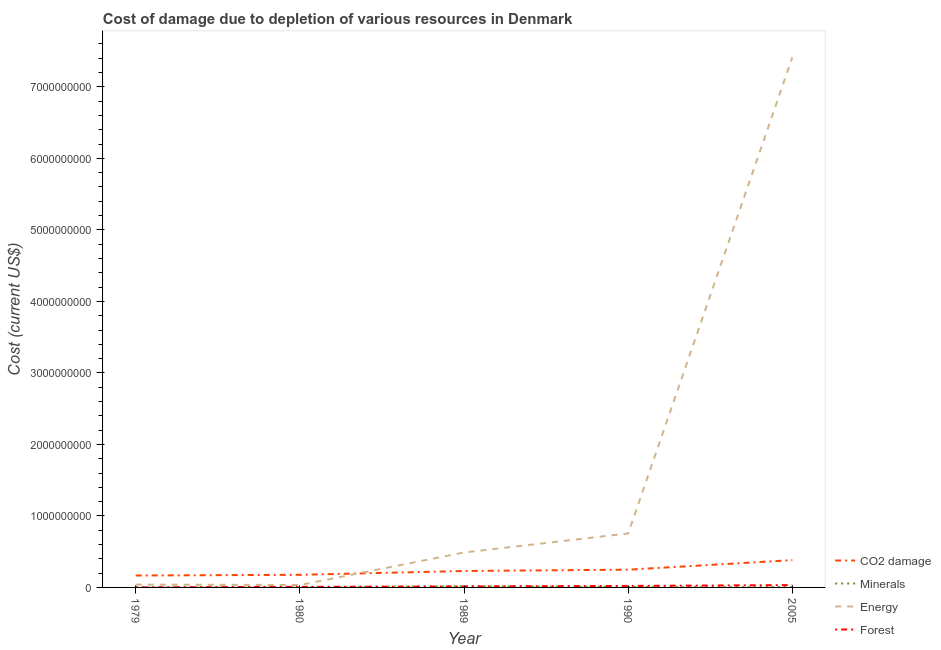How many different coloured lines are there?
Ensure brevity in your answer.  4. Is the number of lines equal to the number of legend labels?
Give a very brief answer. Yes. What is the cost of damage due to depletion of coal in 1989?
Keep it short and to the point. 2.30e+08. Across all years, what is the maximum cost of damage due to depletion of coal?
Ensure brevity in your answer.  3.82e+08. Across all years, what is the minimum cost of damage due to depletion of energy?
Provide a short and direct response. 3.40e+07. In which year was the cost of damage due to depletion of energy maximum?
Your response must be concise. 2005. In which year was the cost of damage due to depletion of forests minimum?
Make the answer very short. 1979. What is the total cost of damage due to depletion of coal in the graph?
Give a very brief answer. 1.20e+09. What is the difference between the cost of damage due to depletion of minerals in 1979 and that in 1989?
Offer a terse response. -1.66e+07. What is the difference between the cost of damage due to depletion of energy in 1989 and the cost of damage due to depletion of coal in 1979?
Your answer should be compact. 3.22e+08. What is the average cost of damage due to depletion of minerals per year?
Offer a terse response. 6.03e+06. In the year 1980, what is the difference between the cost of damage due to depletion of minerals and cost of damage due to depletion of forests?
Provide a short and direct response. -6.27e+06. In how many years, is the cost of damage due to depletion of coal greater than 2800000000 US$?
Your response must be concise. 0. What is the ratio of the cost of damage due to depletion of minerals in 1980 to that in 2005?
Give a very brief answer. 0.41. What is the difference between the highest and the second highest cost of damage due to depletion of energy?
Give a very brief answer. 6.66e+09. What is the difference between the highest and the lowest cost of damage due to depletion of minerals?
Offer a terse response. 1.66e+07. In how many years, is the cost of damage due to depletion of coal greater than the average cost of damage due to depletion of coal taken over all years?
Your answer should be compact. 2. Is the sum of the cost of damage due to depletion of coal in 1989 and 2005 greater than the maximum cost of damage due to depletion of minerals across all years?
Your answer should be very brief. Yes. Is it the case that in every year, the sum of the cost of damage due to depletion of coal and cost of damage due to depletion of minerals is greater than the cost of damage due to depletion of energy?
Offer a very short reply. No. Is the cost of damage due to depletion of energy strictly greater than the cost of damage due to depletion of forests over the years?
Give a very brief answer. Yes. Is the cost of damage due to depletion of energy strictly less than the cost of damage due to depletion of minerals over the years?
Offer a terse response. No. How many lines are there?
Your answer should be compact. 4. How many years are there in the graph?
Keep it short and to the point. 5. What is the difference between two consecutive major ticks on the Y-axis?
Offer a terse response. 1.00e+09. Are the values on the major ticks of Y-axis written in scientific E-notation?
Offer a terse response. No. Does the graph contain any zero values?
Your answer should be compact. No. Where does the legend appear in the graph?
Ensure brevity in your answer.  Bottom right. What is the title of the graph?
Offer a terse response. Cost of damage due to depletion of various resources in Denmark . Does "HFC gas" appear as one of the legend labels in the graph?
Your answer should be very brief. No. What is the label or title of the X-axis?
Your answer should be compact. Year. What is the label or title of the Y-axis?
Offer a terse response. Cost (current US$). What is the Cost (current US$) in CO2 damage in 1979?
Make the answer very short. 1.67e+08. What is the Cost (current US$) of Minerals in 1979?
Provide a short and direct response. 1.76e+05. What is the Cost (current US$) in Energy in 1979?
Provide a short and direct response. 3.92e+07. What is the Cost (current US$) in Forest in 1979?
Your answer should be compact. 5.20e+05. What is the Cost (current US$) in CO2 damage in 1980?
Provide a short and direct response. 1.76e+08. What is the Cost (current US$) of Minerals in 1980?
Your answer should be very brief. 1.95e+06. What is the Cost (current US$) of Energy in 1980?
Provide a short and direct response. 3.40e+07. What is the Cost (current US$) of Forest in 1980?
Offer a very short reply. 8.22e+06. What is the Cost (current US$) of CO2 damage in 1989?
Offer a terse response. 2.30e+08. What is the Cost (current US$) in Minerals in 1989?
Offer a very short reply. 1.68e+07. What is the Cost (current US$) of Energy in 1989?
Your answer should be very brief. 4.89e+08. What is the Cost (current US$) of Forest in 1989?
Offer a terse response. 1.32e+07. What is the Cost (current US$) of CO2 damage in 1990?
Your answer should be compact. 2.48e+08. What is the Cost (current US$) in Minerals in 1990?
Give a very brief answer. 6.54e+06. What is the Cost (current US$) of Energy in 1990?
Keep it short and to the point. 7.55e+08. What is the Cost (current US$) of Forest in 1990?
Your answer should be compact. 2.11e+07. What is the Cost (current US$) of CO2 damage in 2005?
Your answer should be very brief. 3.82e+08. What is the Cost (current US$) of Minerals in 2005?
Provide a succinct answer. 4.71e+06. What is the Cost (current US$) in Energy in 2005?
Your response must be concise. 7.41e+09. What is the Cost (current US$) of Forest in 2005?
Provide a short and direct response. 3.23e+07. Across all years, what is the maximum Cost (current US$) in CO2 damage?
Your answer should be compact. 3.82e+08. Across all years, what is the maximum Cost (current US$) in Minerals?
Offer a terse response. 1.68e+07. Across all years, what is the maximum Cost (current US$) of Energy?
Provide a short and direct response. 7.41e+09. Across all years, what is the maximum Cost (current US$) of Forest?
Your answer should be compact. 3.23e+07. Across all years, what is the minimum Cost (current US$) in CO2 damage?
Your answer should be very brief. 1.67e+08. Across all years, what is the minimum Cost (current US$) of Minerals?
Your answer should be compact. 1.76e+05. Across all years, what is the minimum Cost (current US$) in Energy?
Make the answer very short. 3.40e+07. Across all years, what is the minimum Cost (current US$) of Forest?
Give a very brief answer. 5.20e+05. What is the total Cost (current US$) in CO2 damage in the graph?
Offer a very short reply. 1.20e+09. What is the total Cost (current US$) in Minerals in the graph?
Provide a succinct answer. 3.02e+07. What is the total Cost (current US$) of Energy in the graph?
Your response must be concise. 8.73e+09. What is the total Cost (current US$) in Forest in the graph?
Offer a terse response. 7.53e+07. What is the difference between the Cost (current US$) in CO2 damage in 1979 and that in 1980?
Offer a very short reply. -9.51e+06. What is the difference between the Cost (current US$) in Minerals in 1979 and that in 1980?
Offer a terse response. -1.78e+06. What is the difference between the Cost (current US$) in Energy in 1979 and that in 1980?
Provide a short and direct response. 5.26e+06. What is the difference between the Cost (current US$) in Forest in 1979 and that in 1980?
Ensure brevity in your answer.  -7.70e+06. What is the difference between the Cost (current US$) in CO2 damage in 1979 and that in 1989?
Give a very brief answer. -6.29e+07. What is the difference between the Cost (current US$) in Minerals in 1979 and that in 1989?
Offer a terse response. -1.66e+07. What is the difference between the Cost (current US$) of Energy in 1979 and that in 1989?
Offer a terse response. -4.49e+08. What is the difference between the Cost (current US$) in Forest in 1979 and that in 1989?
Provide a succinct answer. -1.26e+07. What is the difference between the Cost (current US$) in CO2 damage in 1979 and that in 1990?
Your response must be concise. -8.13e+07. What is the difference between the Cost (current US$) of Minerals in 1979 and that in 1990?
Offer a terse response. -6.36e+06. What is the difference between the Cost (current US$) of Energy in 1979 and that in 1990?
Your response must be concise. -7.16e+08. What is the difference between the Cost (current US$) in Forest in 1979 and that in 1990?
Your answer should be compact. -2.06e+07. What is the difference between the Cost (current US$) in CO2 damage in 1979 and that in 2005?
Provide a succinct answer. -2.15e+08. What is the difference between the Cost (current US$) of Minerals in 1979 and that in 2005?
Your answer should be very brief. -4.53e+06. What is the difference between the Cost (current US$) of Energy in 1979 and that in 2005?
Offer a terse response. -7.37e+09. What is the difference between the Cost (current US$) of Forest in 1979 and that in 2005?
Offer a terse response. -3.18e+07. What is the difference between the Cost (current US$) in CO2 damage in 1980 and that in 1989?
Your response must be concise. -5.34e+07. What is the difference between the Cost (current US$) in Minerals in 1980 and that in 1989?
Provide a short and direct response. -1.48e+07. What is the difference between the Cost (current US$) in Energy in 1980 and that in 1989?
Your response must be concise. -4.55e+08. What is the difference between the Cost (current US$) of Forest in 1980 and that in 1989?
Provide a succinct answer. -4.93e+06. What is the difference between the Cost (current US$) in CO2 damage in 1980 and that in 1990?
Your answer should be very brief. -7.18e+07. What is the difference between the Cost (current US$) of Minerals in 1980 and that in 1990?
Provide a short and direct response. -4.59e+06. What is the difference between the Cost (current US$) of Energy in 1980 and that in 1990?
Your answer should be very brief. -7.21e+08. What is the difference between the Cost (current US$) of Forest in 1980 and that in 1990?
Ensure brevity in your answer.  -1.29e+07. What is the difference between the Cost (current US$) in CO2 damage in 1980 and that in 2005?
Make the answer very short. -2.05e+08. What is the difference between the Cost (current US$) of Minerals in 1980 and that in 2005?
Keep it short and to the point. -2.76e+06. What is the difference between the Cost (current US$) in Energy in 1980 and that in 2005?
Make the answer very short. -7.38e+09. What is the difference between the Cost (current US$) of Forest in 1980 and that in 2005?
Offer a very short reply. -2.41e+07. What is the difference between the Cost (current US$) of CO2 damage in 1989 and that in 1990?
Your answer should be compact. -1.84e+07. What is the difference between the Cost (current US$) in Minerals in 1989 and that in 1990?
Keep it short and to the point. 1.02e+07. What is the difference between the Cost (current US$) of Energy in 1989 and that in 1990?
Offer a very short reply. -2.66e+08. What is the difference between the Cost (current US$) of Forest in 1989 and that in 1990?
Offer a terse response. -7.95e+06. What is the difference between the Cost (current US$) in CO2 damage in 1989 and that in 2005?
Keep it short and to the point. -1.52e+08. What is the difference between the Cost (current US$) in Minerals in 1989 and that in 2005?
Offer a very short reply. 1.21e+07. What is the difference between the Cost (current US$) of Energy in 1989 and that in 2005?
Your response must be concise. -6.92e+09. What is the difference between the Cost (current US$) of Forest in 1989 and that in 2005?
Give a very brief answer. -1.92e+07. What is the difference between the Cost (current US$) of CO2 damage in 1990 and that in 2005?
Keep it short and to the point. -1.34e+08. What is the difference between the Cost (current US$) of Minerals in 1990 and that in 2005?
Give a very brief answer. 1.83e+06. What is the difference between the Cost (current US$) in Energy in 1990 and that in 2005?
Your answer should be compact. -6.66e+09. What is the difference between the Cost (current US$) of Forest in 1990 and that in 2005?
Provide a succinct answer. -1.12e+07. What is the difference between the Cost (current US$) in CO2 damage in 1979 and the Cost (current US$) in Minerals in 1980?
Provide a short and direct response. 1.65e+08. What is the difference between the Cost (current US$) of CO2 damage in 1979 and the Cost (current US$) of Energy in 1980?
Offer a terse response. 1.33e+08. What is the difference between the Cost (current US$) in CO2 damage in 1979 and the Cost (current US$) in Forest in 1980?
Ensure brevity in your answer.  1.59e+08. What is the difference between the Cost (current US$) of Minerals in 1979 and the Cost (current US$) of Energy in 1980?
Ensure brevity in your answer.  -3.38e+07. What is the difference between the Cost (current US$) of Minerals in 1979 and the Cost (current US$) of Forest in 1980?
Keep it short and to the point. -8.05e+06. What is the difference between the Cost (current US$) of Energy in 1979 and the Cost (current US$) of Forest in 1980?
Provide a short and direct response. 3.10e+07. What is the difference between the Cost (current US$) in CO2 damage in 1979 and the Cost (current US$) in Minerals in 1989?
Keep it short and to the point. 1.50e+08. What is the difference between the Cost (current US$) in CO2 damage in 1979 and the Cost (current US$) in Energy in 1989?
Your answer should be compact. -3.22e+08. What is the difference between the Cost (current US$) in CO2 damage in 1979 and the Cost (current US$) in Forest in 1989?
Provide a succinct answer. 1.54e+08. What is the difference between the Cost (current US$) of Minerals in 1979 and the Cost (current US$) of Energy in 1989?
Offer a very short reply. -4.89e+08. What is the difference between the Cost (current US$) of Minerals in 1979 and the Cost (current US$) of Forest in 1989?
Your answer should be very brief. -1.30e+07. What is the difference between the Cost (current US$) of Energy in 1979 and the Cost (current US$) of Forest in 1989?
Offer a terse response. 2.61e+07. What is the difference between the Cost (current US$) of CO2 damage in 1979 and the Cost (current US$) of Minerals in 1990?
Offer a very short reply. 1.60e+08. What is the difference between the Cost (current US$) in CO2 damage in 1979 and the Cost (current US$) in Energy in 1990?
Provide a succinct answer. -5.88e+08. What is the difference between the Cost (current US$) of CO2 damage in 1979 and the Cost (current US$) of Forest in 1990?
Offer a very short reply. 1.46e+08. What is the difference between the Cost (current US$) in Minerals in 1979 and the Cost (current US$) in Energy in 1990?
Keep it short and to the point. -7.55e+08. What is the difference between the Cost (current US$) in Minerals in 1979 and the Cost (current US$) in Forest in 1990?
Your response must be concise. -2.09e+07. What is the difference between the Cost (current US$) in Energy in 1979 and the Cost (current US$) in Forest in 1990?
Offer a terse response. 1.81e+07. What is the difference between the Cost (current US$) in CO2 damage in 1979 and the Cost (current US$) in Minerals in 2005?
Offer a very short reply. 1.62e+08. What is the difference between the Cost (current US$) in CO2 damage in 1979 and the Cost (current US$) in Energy in 2005?
Your answer should be very brief. -7.25e+09. What is the difference between the Cost (current US$) in CO2 damage in 1979 and the Cost (current US$) in Forest in 2005?
Your answer should be very brief. 1.35e+08. What is the difference between the Cost (current US$) in Minerals in 1979 and the Cost (current US$) in Energy in 2005?
Ensure brevity in your answer.  -7.41e+09. What is the difference between the Cost (current US$) in Minerals in 1979 and the Cost (current US$) in Forest in 2005?
Keep it short and to the point. -3.22e+07. What is the difference between the Cost (current US$) of Energy in 1979 and the Cost (current US$) of Forest in 2005?
Make the answer very short. 6.89e+06. What is the difference between the Cost (current US$) in CO2 damage in 1980 and the Cost (current US$) in Minerals in 1989?
Ensure brevity in your answer.  1.60e+08. What is the difference between the Cost (current US$) in CO2 damage in 1980 and the Cost (current US$) in Energy in 1989?
Offer a terse response. -3.12e+08. What is the difference between the Cost (current US$) in CO2 damage in 1980 and the Cost (current US$) in Forest in 1989?
Your response must be concise. 1.63e+08. What is the difference between the Cost (current US$) of Minerals in 1980 and the Cost (current US$) of Energy in 1989?
Offer a very short reply. -4.87e+08. What is the difference between the Cost (current US$) of Minerals in 1980 and the Cost (current US$) of Forest in 1989?
Make the answer very short. -1.12e+07. What is the difference between the Cost (current US$) of Energy in 1980 and the Cost (current US$) of Forest in 1989?
Provide a succinct answer. 2.08e+07. What is the difference between the Cost (current US$) in CO2 damage in 1980 and the Cost (current US$) in Minerals in 1990?
Your answer should be compact. 1.70e+08. What is the difference between the Cost (current US$) of CO2 damage in 1980 and the Cost (current US$) of Energy in 1990?
Give a very brief answer. -5.79e+08. What is the difference between the Cost (current US$) in CO2 damage in 1980 and the Cost (current US$) in Forest in 1990?
Ensure brevity in your answer.  1.55e+08. What is the difference between the Cost (current US$) of Minerals in 1980 and the Cost (current US$) of Energy in 1990?
Offer a very short reply. -7.53e+08. What is the difference between the Cost (current US$) of Minerals in 1980 and the Cost (current US$) of Forest in 1990?
Your response must be concise. -1.92e+07. What is the difference between the Cost (current US$) of Energy in 1980 and the Cost (current US$) of Forest in 1990?
Provide a short and direct response. 1.29e+07. What is the difference between the Cost (current US$) of CO2 damage in 1980 and the Cost (current US$) of Minerals in 2005?
Provide a succinct answer. 1.72e+08. What is the difference between the Cost (current US$) of CO2 damage in 1980 and the Cost (current US$) of Energy in 2005?
Provide a short and direct response. -7.24e+09. What is the difference between the Cost (current US$) of CO2 damage in 1980 and the Cost (current US$) of Forest in 2005?
Provide a succinct answer. 1.44e+08. What is the difference between the Cost (current US$) in Minerals in 1980 and the Cost (current US$) in Energy in 2005?
Offer a terse response. -7.41e+09. What is the difference between the Cost (current US$) in Minerals in 1980 and the Cost (current US$) in Forest in 2005?
Provide a short and direct response. -3.04e+07. What is the difference between the Cost (current US$) in Energy in 1980 and the Cost (current US$) in Forest in 2005?
Ensure brevity in your answer.  1.63e+06. What is the difference between the Cost (current US$) of CO2 damage in 1989 and the Cost (current US$) of Minerals in 1990?
Give a very brief answer. 2.23e+08. What is the difference between the Cost (current US$) in CO2 damage in 1989 and the Cost (current US$) in Energy in 1990?
Your answer should be compact. -5.25e+08. What is the difference between the Cost (current US$) in CO2 damage in 1989 and the Cost (current US$) in Forest in 1990?
Keep it short and to the point. 2.09e+08. What is the difference between the Cost (current US$) of Minerals in 1989 and the Cost (current US$) of Energy in 1990?
Your answer should be very brief. -7.38e+08. What is the difference between the Cost (current US$) in Minerals in 1989 and the Cost (current US$) in Forest in 1990?
Make the answer very short. -4.32e+06. What is the difference between the Cost (current US$) of Energy in 1989 and the Cost (current US$) of Forest in 1990?
Provide a short and direct response. 4.68e+08. What is the difference between the Cost (current US$) in CO2 damage in 1989 and the Cost (current US$) in Minerals in 2005?
Offer a terse response. 2.25e+08. What is the difference between the Cost (current US$) in CO2 damage in 1989 and the Cost (current US$) in Energy in 2005?
Provide a short and direct response. -7.18e+09. What is the difference between the Cost (current US$) of CO2 damage in 1989 and the Cost (current US$) of Forest in 2005?
Keep it short and to the point. 1.97e+08. What is the difference between the Cost (current US$) of Minerals in 1989 and the Cost (current US$) of Energy in 2005?
Your response must be concise. -7.40e+09. What is the difference between the Cost (current US$) in Minerals in 1989 and the Cost (current US$) in Forest in 2005?
Offer a terse response. -1.56e+07. What is the difference between the Cost (current US$) in Energy in 1989 and the Cost (current US$) in Forest in 2005?
Your answer should be compact. 4.56e+08. What is the difference between the Cost (current US$) in CO2 damage in 1990 and the Cost (current US$) in Minerals in 2005?
Keep it short and to the point. 2.43e+08. What is the difference between the Cost (current US$) of CO2 damage in 1990 and the Cost (current US$) of Energy in 2005?
Your answer should be very brief. -7.17e+09. What is the difference between the Cost (current US$) in CO2 damage in 1990 and the Cost (current US$) in Forest in 2005?
Your answer should be compact. 2.16e+08. What is the difference between the Cost (current US$) in Minerals in 1990 and the Cost (current US$) in Energy in 2005?
Provide a succinct answer. -7.41e+09. What is the difference between the Cost (current US$) of Minerals in 1990 and the Cost (current US$) of Forest in 2005?
Your answer should be very brief. -2.58e+07. What is the difference between the Cost (current US$) of Energy in 1990 and the Cost (current US$) of Forest in 2005?
Offer a terse response. 7.23e+08. What is the average Cost (current US$) in CO2 damage per year?
Ensure brevity in your answer.  2.41e+08. What is the average Cost (current US$) in Minerals per year?
Provide a succinct answer. 6.03e+06. What is the average Cost (current US$) in Energy per year?
Provide a succinct answer. 1.75e+09. What is the average Cost (current US$) of Forest per year?
Make the answer very short. 1.51e+07. In the year 1979, what is the difference between the Cost (current US$) of CO2 damage and Cost (current US$) of Minerals?
Make the answer very short. 1.67e+08. In the year 1979, what is the difference between the Cost (current US$) of CO2 damage and Cost (current US$) of Energy?
Offer a terse response. 1.28e+08. In the year 1979, what is the difference between the Cost (current US$) of CO2 damage and Cost (current US$) of Forest?
Give a very brief answer. 1.66e+08. In the year 1979, what is the difference between the Cost (current US$) of Minerals and Cost (current US$) of Energy?
Your response must be concise. -3.91e+07. In the year 1979, what is the difference between the Cost (current US$) in Minerals and Cost (current US$) in Forest?
Your answer should be compact. -3.44e+05. In the year 1979, what is the difference between the Cost (current US$) of Energy and Cost (current US$) of Forest?
Your answer should be compact. 3.87e+07. In the year 1980, what is the difference between the Cost (current US$) in CO2 damage and Cost (current US$) in Minerals?
Ensure brevity in your answer.  1.74e+08. In the year 1980, what is the difference between the Cost (current US$) of CO2 damage and Cost (current US$) of Energy?
Provide a short and direct response. 1.42e+08. In the year 1980, what is the difference between the Cost (current US$) of CO2 damage and Cost (current US$) of Forest?
Provide a succinct answer. 1.68e+08. In the year 1980, what is the difference between the Cost (current US$) of Minerals and Cost (current US$) of Energy?
Offer a terse response. -3.20e+07. In the year 1980, what is the difference between the Cost (current US$) in Minerals and Cost (current US$) in Forest?
Provide a succinct answer. -6.27e+06. In the year 1980, what is the difference between the Cost (current US$) of Energy and Cost (current US$) of Forest?
Offer a terse response. 2.58e+07. In the year 1989, what is the difference between the Cost (current US$) of CO2 damage and Cost (current US$) of Minerals?
Provide a succinct answer. 2.13e+08. In the year 1989, what is the difference between the Cost (current US$) in CO2 damage and Cost (current US$) in Energy?
Ensure brevity in your answer.  -2.59e+08. In the year 1989, what is the difference between the Cost (current US$) in CO2 damage and Cost (current US$) in Forest?
Your answer should be compact. 2.17e+08. In the year 1989, what is the difference between the Cost (current US$) of Minerals and Cost (current US$) of Energy?
Your answer should be very brief. -4.72e+08. In the year 1989, what is the difference between the Cost (current US$) in Minerals and Cost (current US$) in Forest?
Provide a short and direct response. 3.63e+06. In the year 1989, what is the difference between the Cost (current US$) of Energy and Cost (current US$) of Forest?
Offer a very short reply. 4.76e+08. In the year 1990, what is the difference between the Cost (current US$) in CO2 damage and Cost (current US$) in Minerals?
Provide a short and direct response. 2.42e+08. In the year 1990, what is the difference between the Cost (current US$) in CO2 damage and Cost (current US$) in Energy?
Offer a terse response. -5.07e+08. In the year 1990, what is the difference between the Cost (current US$) of CO2 damage and Cost (current US$) of Forest?
Provide a succinct answer. 2.27e+08. In the year 1990, what is the difference between the Cost (current US$) of Minerals and Cost (current US$) of Energy?
Offer a terse response. -7.49e+08. In the year 1990, what is the difference between the Cost (current US$) of Minerals and Cost (current US$) of Forest?
Give a very brief answer. -1.46e+07. In the year 1990, what is the difference between the Cost (current US$) in Energy and Cost (current US$) in Forest?
Make the answer very short. 7.34e+08. In the year 2005, what is the difference between the Cost (current US$) of CO2 damage and Cost (current US$) of Minerals?
Offer a terse response. 3.77e+08. In the year 2005, what is the difference between the Cost (current US$) of CO2 damage and Cost (current US$) of Energy?
Offer a terse response. -7.03e+09. In the year 2005, what is the difference between the Cost (current US$) in CO2 damage and Cost (current US$) in Forest?
Keep it short and to the point. 3.49e+08. In the year 2005, what is the difference between the Cost (current US$) of Minerals and Cost (current US$) of Energy?
Offer a terse response. -7.41e+09. In the year 2005, what is the difference between the Cost (current US$) of Minerals and Cost (current US$) of Forest?
Your answer should be very brief. -2.76e+07. In the year 2005, what is the difference between the Cost (current US$) of Energy and Cost (current US$) of Forest?
Your answer should be very brief. 7.38e+09. What is the ratio of the Cost (current US$) in CO2 damage in 1979 to that in 1980?
Offer a terse response. 0.95. What is the ratio of the Cost (current US$) of Minerals in 1979 to that in 1980?
Provide a short and direct response. 0.09. What is the ratio of the Cost (current US$) of Energy in 1979 to that in 1980?
Offer a terse response. 1.15. What is the ratio of the Cost (current US$) of Forest in 1979 to that in 1980?
Make the answer very short. 0.06. What is the ratio of the Cost (current US$) of CO2 damage in 1979 to that in 1989?
Ensure brevity in your answer.  0.73. What is the ratio of the Cost (current US$) in Minerals in 1979 to that in 1989?
Give a very brief answer. 0.01. What is the ratio of the Cost (current US$) of Energy in 1979 to that in 1989?
Ensure brevity in your answer.  0.08. What is the ratio of the Cost (current US$) of Forest in 1979 to that in 1989?
Make the answer very short. 0.04. What is the ratio of the Cost (current US$) in CO2 damage in 1979 to that in 1990?
Provide a short and direct response. 0.67. What is the ratio of the Cost (current US$) in Minerals in 1979 to that in 1990?
Offer a very short reply. 0.03. What is the ratio of the Cost (current US$) of Energy in 1979 to that in 1990?
Your response must be concise. 0.05. What is the ratio of the Cost (current US$) in Forest in 1979 to that in 1990?
Offer a very short reply. 0.02. What is the ratio of the Cost (current US$) of CO2 damage in 1979 to that in 2005?
Offer a very short reply. 0.44. What is the ratio of the Cost (current US$) in Minerals in 1979 to that in 2005?
Keep it short and to the point. 0.04. What is the ratio of the Cost (current US$) of Energy in 1979 to that in 2005?
Ensure brevity in your answer.  0.01. What is the ratio of the Cost (current US$) of Forest in 1979 to that in 2005?
Offer a terse response. 0.02. What is the ratio of the Cost (current US$) in CO2 damage in 1980 to that in 1989?
Your answer should be compact. 0.77. What is the ratio of the Cost (current US$) of Minerals in 1980 to that in 1989?
Ensure brevity in your answer.  0.12. What is the ratio of the Cost (current US$) in Energy in 1980 to that in 1989?
Ensure brevity in your answer.  0.07. What is the ratio of the Cost (current US$) in Forest in 1980 to that in 1989?
Your answer should be very brief. 0.63. What is the ratio of the Cost (current US$) in CO2 damage in 1980 to that in 1990?
Your response must be concise. 0.71. What is the ratio of the Cost (current US$) in Minerals in 1980 to that in 1990?
Your answer should be very brief. 0.3. What is the ratio of the Cost (current US$) of Energy in 1980 to that in 1990?
Your answer should be compact. 0.04. What is the ratio of the Cost (current US$) of Forest in 1980 to that in 1990?
Ensure brevity in your answer.  0.39. What is the ratio of the Cost (current US$) of CO2 damage in 1980 to that in 2005?
Give a very brief answer. 0.46. What is the ratio of the Cost (current US$) in Minerals in 1980 to that in 2005?
Provide a succinct answer. 0.41. What is the ratio of the Cost (current US$) in Energy in 1980 to that in 2005?
Provide a short and direct response. 0. What is the ratio of the Cost (current US$) of Forest in 1980 to that in 2005?
Keep it short and to the point. 0.25. What is the ratio of the Cost (current US$) of CO2 damage in 1989 to that in 1990?
Your response must be concise. 0.93. What is the ratio of the Cost (current US$) of Minerals in 1989 to that in 1990?
Provide a short and direct response. 2.57. What is the ratio of the Cost (current US$) in Energy in 1989 to that in 1990?
Give a very brief answer. 0.65. What is the ratio of the Cost (current US$) in Forest in 1989 to that in 1990?
Provide a short and direct response. 0.62. What is the ratio of the Cost (current US$) in CO2 damage in 1989 to that in 2005?
Give a very brief answer. 0.6. What is the ratio of the Cost (current US$) in Minerals in 1989 to that in 2005?
Keep it short and to the point. 3.56. What is the ratio of the Cost (current US$) of Energy in 1989 to that in 2005?
Give a very brief answer. 0.07. What is the ratio of the Cost (current US$) of Forest in 1989 to that in 2005?
Your response must be concise. 0.41. What is the ratio of the Cost (current US$) of CO2 damage in 1990 to that in 2005?
Offer a terse response. 0.65. What is the ratio of the Cost (current US$) of Minerals in 1990 to that in 2005?
Offer a very short reply. 1.39. What is the ratio of the Cost (current US$) in Energy in 1990 to that in 2005?
Your answer should be compact. 0.1. What is the ratio of the Cost (current US$) in Forest in 1990 to that in 2005?
Your response must be concise. 0.65. What is the difference between the highest and the second highest Cost (current US$) in CO2 damage?
Offer a very short reply. 1.34e+08. What is the difference between the highest and the second highest Cost (current US$) in Minerals?
Give a very brief answer. 1.02e+07. What is the difference between the highest and the second highest Cost (current US$) of Energy?
Give a very brief answer. 6.66e+09. What is the difference between the highest and the second highest Cost (current US$) in Forest?
Keep it short and to the point. 1.12e+07. What is the difference between the highest and the lowest Cost (current US$) of CO2 damage?
Provide a succinct answer. 2.15e+08. What is the difference between the highest and the lowest Cost (current US$) of Minerals?
Keep it short and to the point. 1.66e+07. What is the difference between the highest and the lowest Cost (current US$) in Energy?
Your response must be concise. 7.38e+09. What is the difference between the highest and the lowest Cost (current US$) of Forest?
Keep it short and to the point. 3.18e+07. 